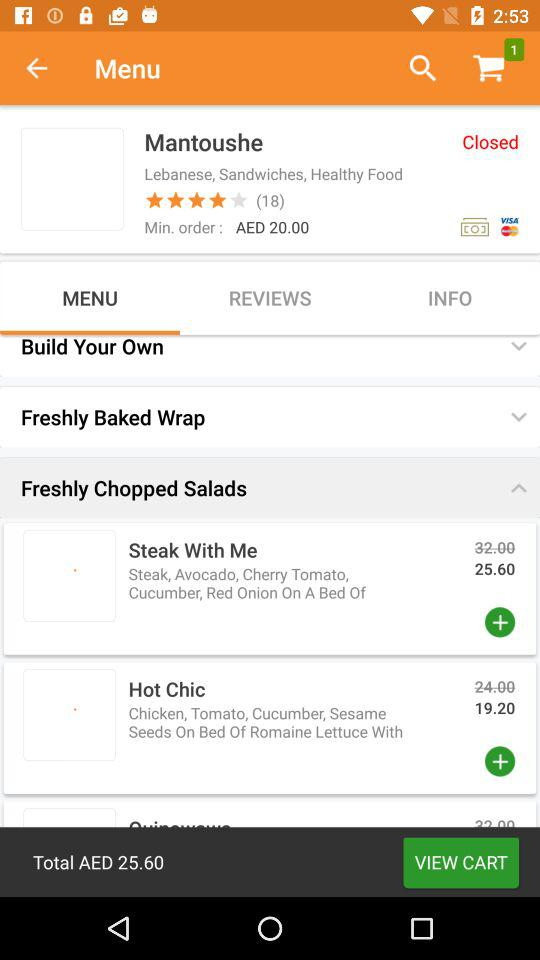What is the name of the hotel? The name of the hotel is Mantoushe. 